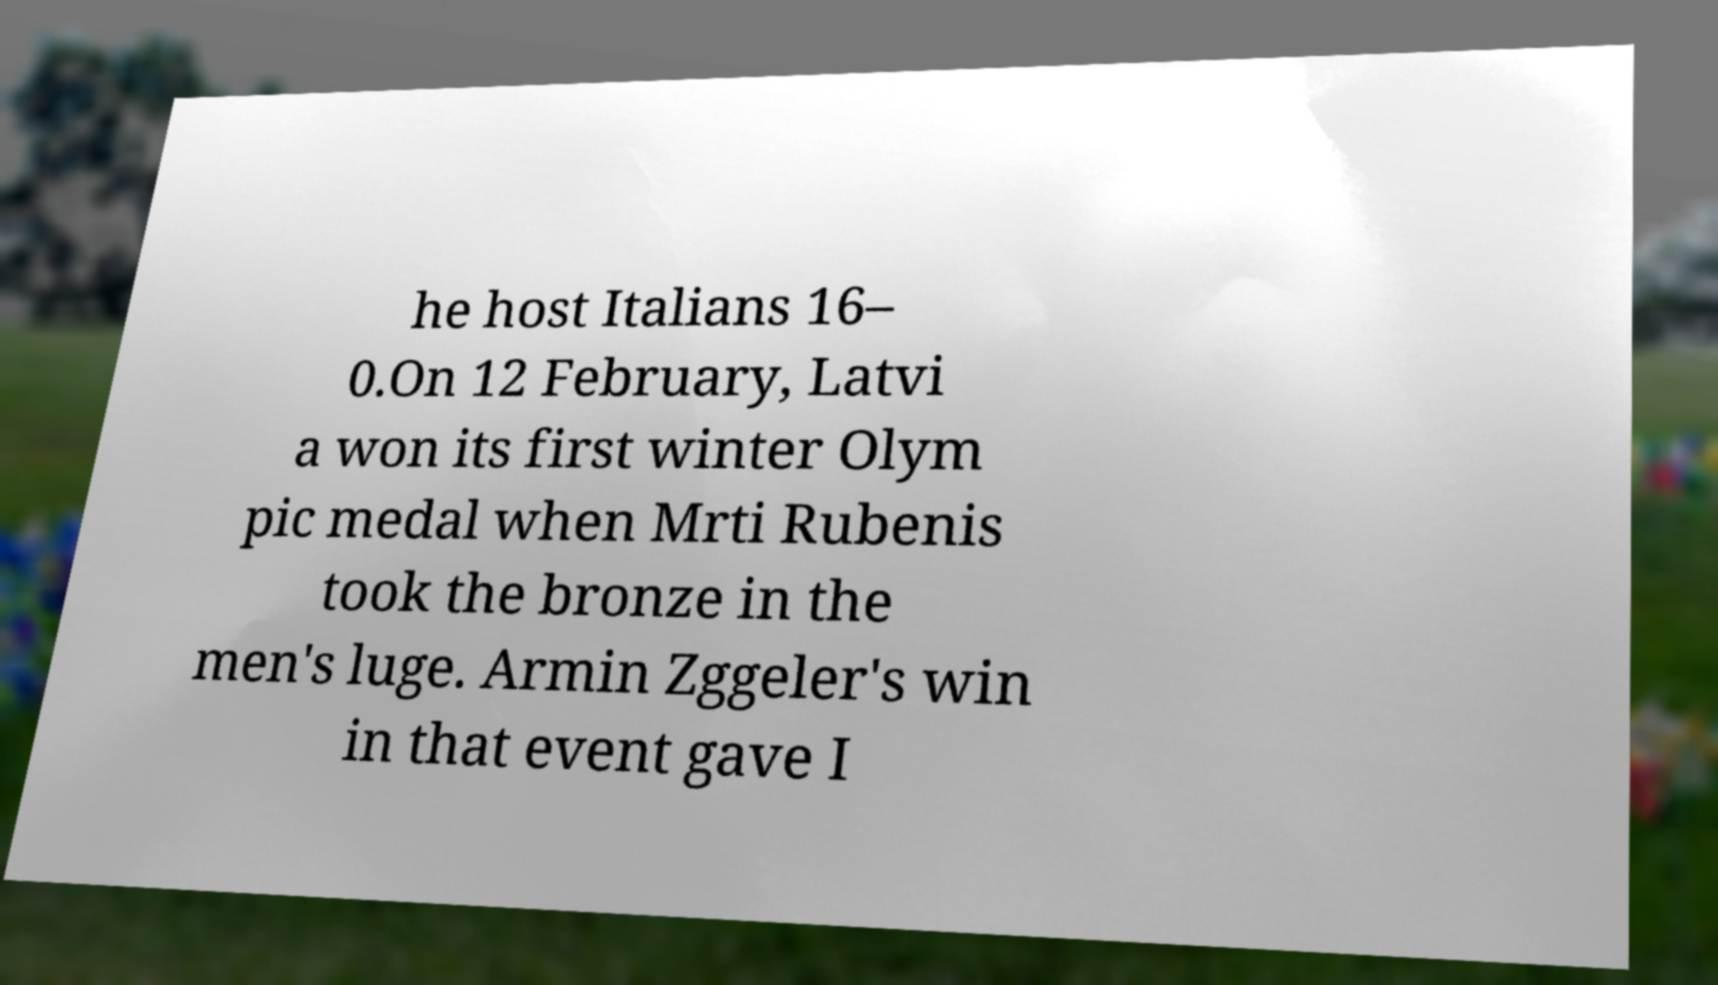I need the written content from this picture converted into text. Can you do that? he host Italians 16– 0.On 12 February, Latvi a won its first winter Olym pic medal when Mrti Rubenis took the bronze in the men's luge. Armin Zggeler's win in that event gave I 